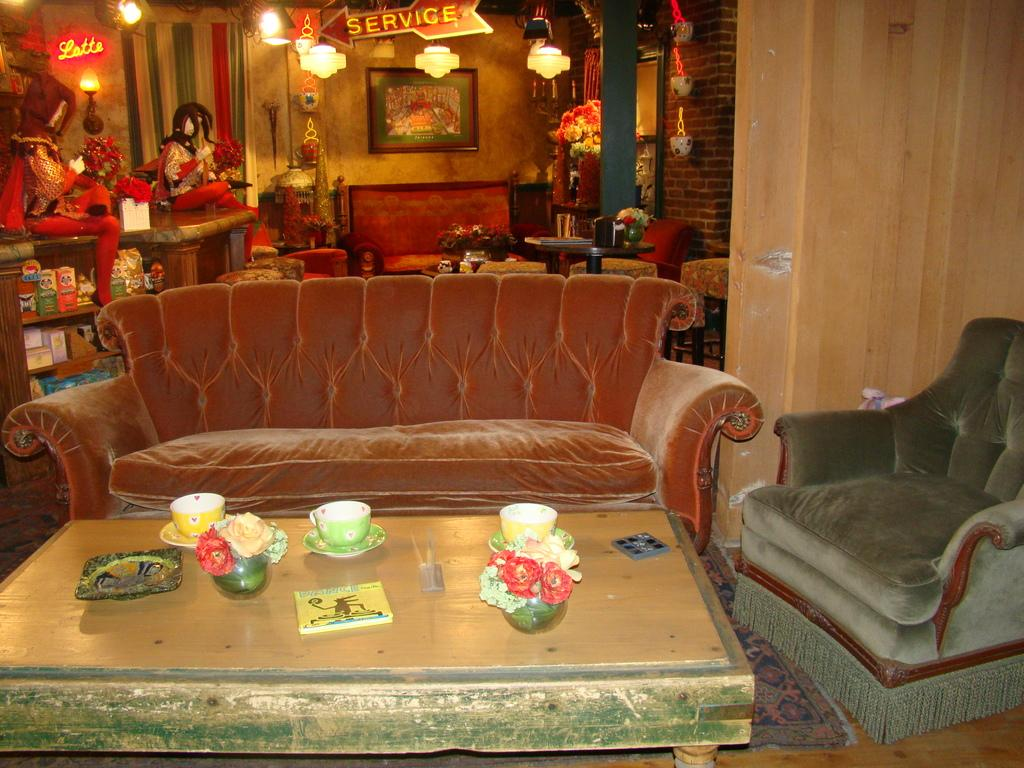What type of furniture is present in the image? There is a sofa and a table in the image. What objects are on the table? There are cups and a flower vase on the table. What can be seen in the background of the image? There is a wall in the background of the image. What is hanging on the wall? There is a frame on the wall. What can be seen illuminating the room? There are lights visible in the image. Can you describe the snake slithering across the table in the image? There is no snake present in the image; it only shows a sofa, table, cups, a flower vase, a wall, a frame, and lights. 